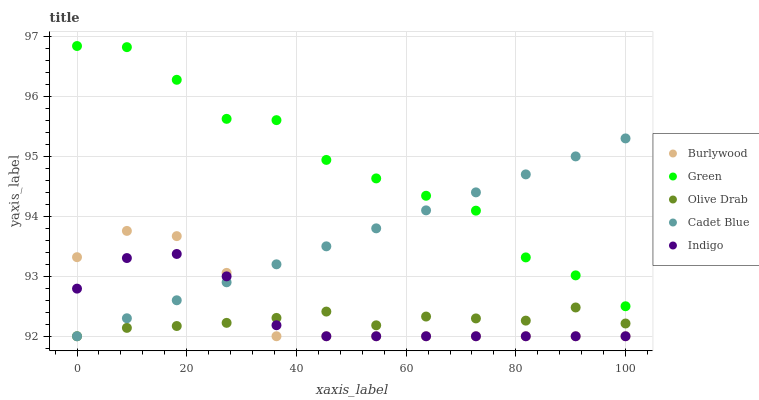Does Olive Drab have the minimum area under the curve?
Answer yes or no. Yes. Does Green have the maximum area under the curve?
Answer yes or no. Yes. Does Indigo have the minimum area under the curve?
Answer yes or no. No. Does Indigo have the maximum area under the curve?
Answer yes or no. No. Is Cadet Blue the smoothest?
Answer yes or no. Yes. Is Green the roughest?
Answer yes or no. Yes. Is Indigo the smoothest?
Answer yes or no. No. Is Indigo the roughest?
Answer yes or no. No. Does Burlywood have the lowest value?
Answer yes or no. Yes. Does Green have the lowest value?
Answer yes or no. No. Does Green have the highest value?
Answer yes or no. Yes. Does Indigo have the highest value?
Answer yes or no. No. Is Indigo less than Green?
Answer yes or no. Yes. Is Green greater than Burlywood?
Answer yes or no. Yes. Does Cadet Blue intersect Olive Drab?
Answer yes or no. Yes. Is Cadet Blue less than Olive Drab?
Answer yes or no. No. Is Cadet Blue greater than Olive Drab?
Answer yes or no. No. Does Indigo intersect Green?
Answer yes or no. No. 